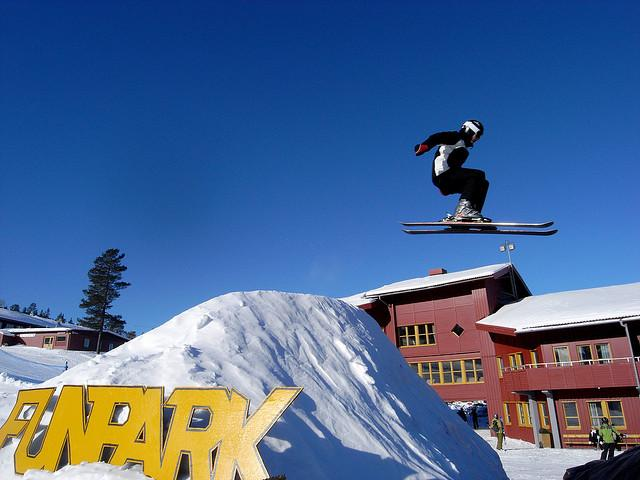What type of sign is shown?

Choices:
A) regulatory
B) orientation
C) location
D) directional location 